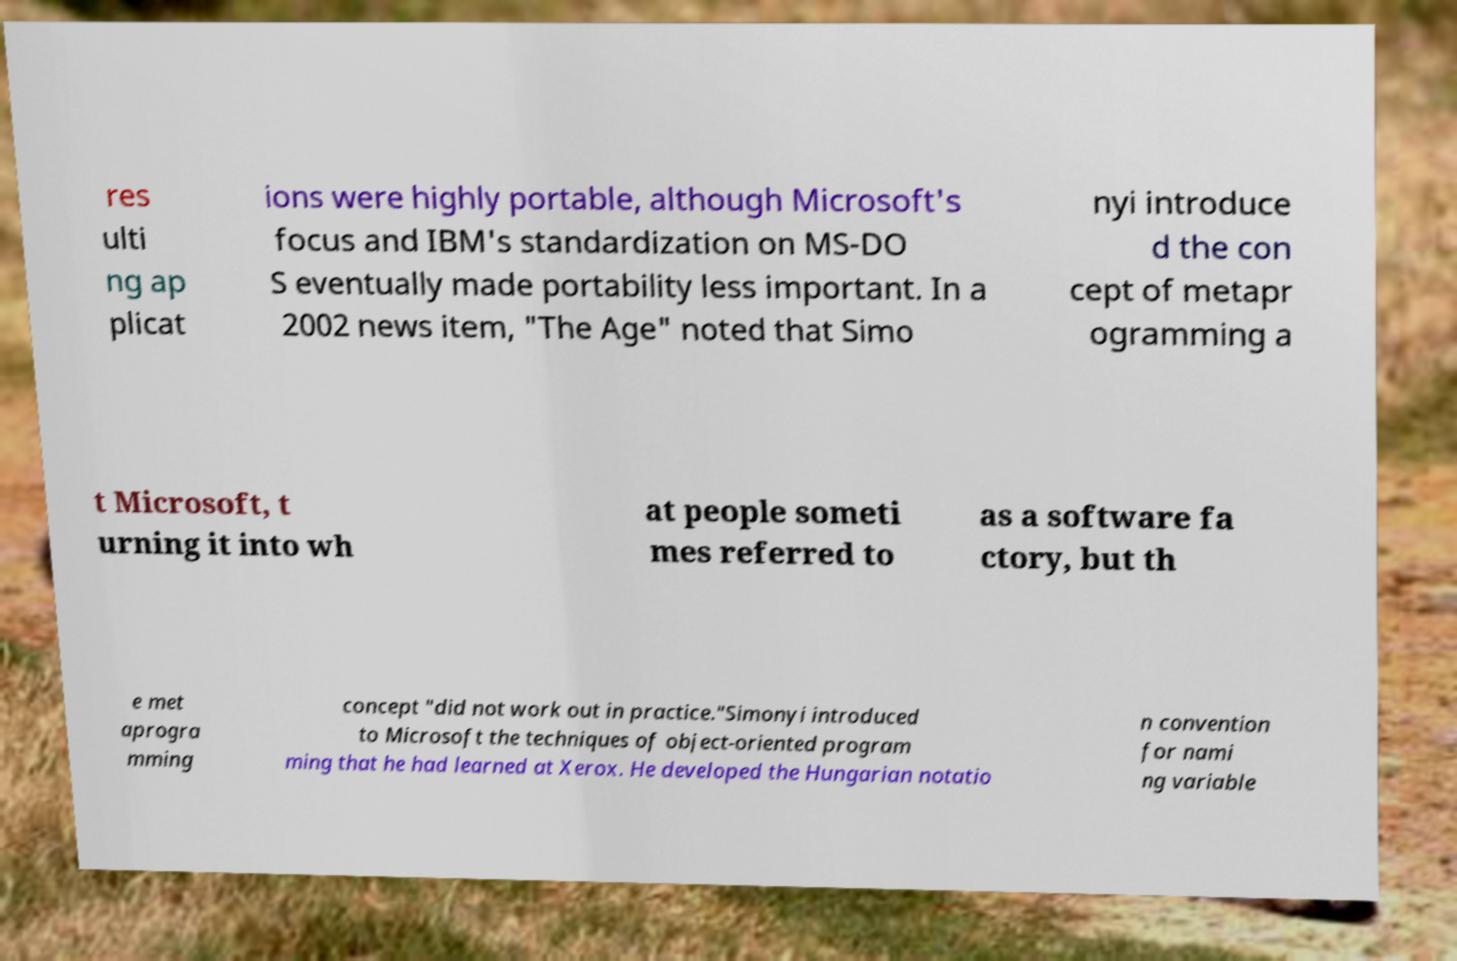I need the written content from this picture converted into text. Can you do that? res ulti ng ap plicat ions were highly portable, although Microsoft's focus and IBM's standardization on MS-DO S eventually made portability less important. In a 2002 news item, "The Age" noted that Simo nyi introduce d the con cept of metapr ogramming a t Microsoft, t urning it into wh at people someti mes referred to as a software fa ctory, but th e met aprogra mming concept "did not work out in practice."Simonyi introduced to Microsoft the techniques of object-oriented program ming that he had learned at Xerox. He developed the Hungarian notatio n convention for nami ng variable 